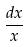Convert formula to latex. <formula><loc_0><loc_0><loc_500><loc_500>\frac { d x } { x }</formula> 